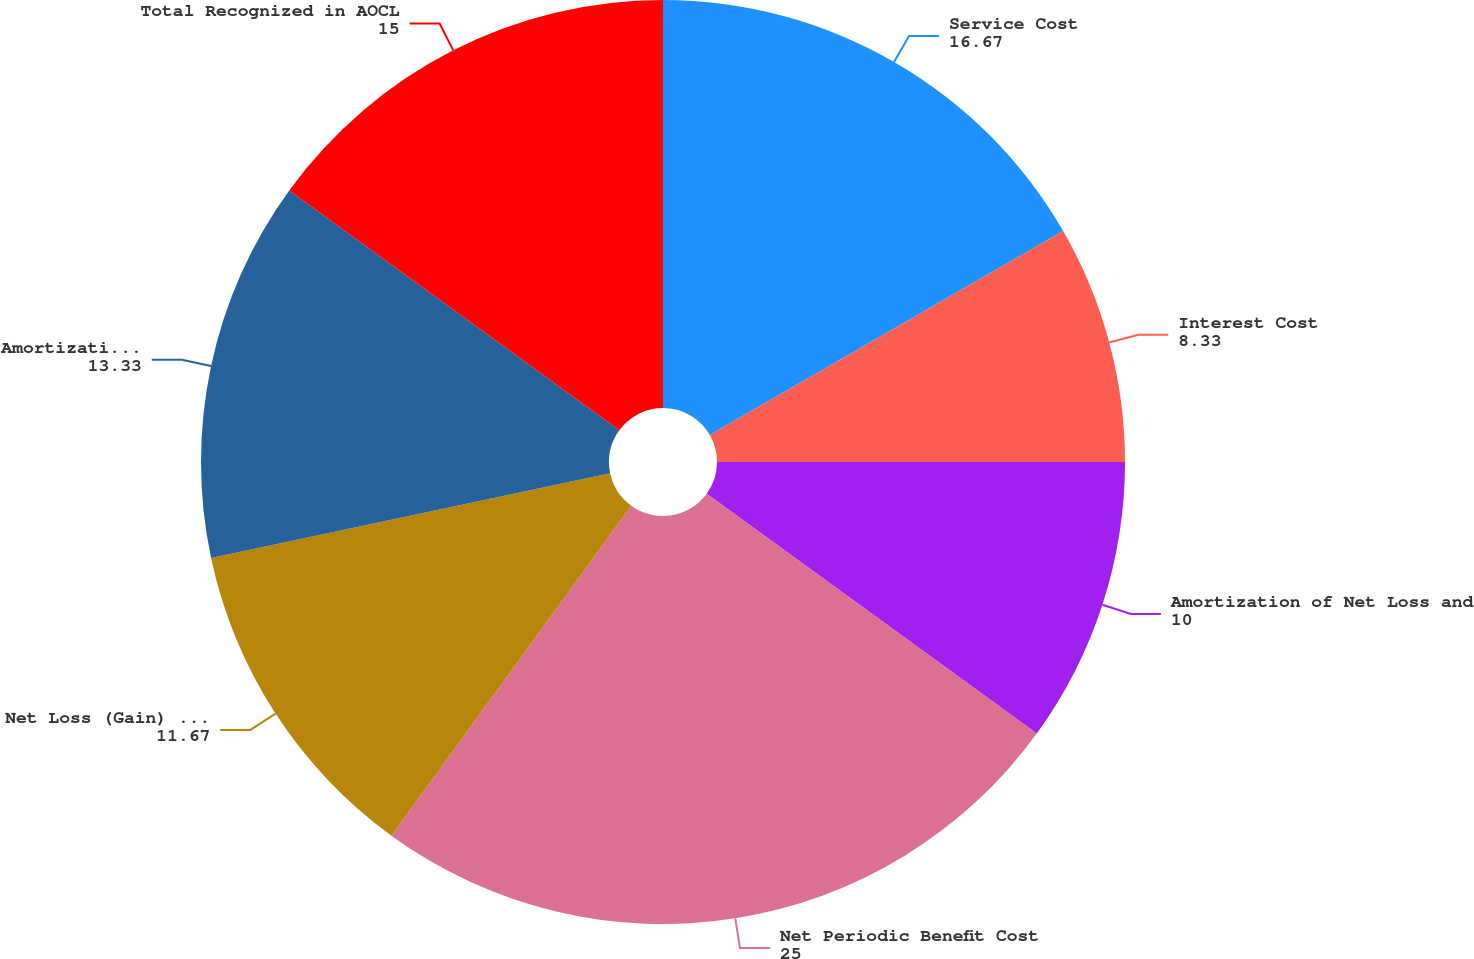<chart> <loc_0><loc_0><loc_500><loc_500><pie_chart><fcel>Service Cost<fcel>Interest Cost<fcel>Amortization of Net Loss and<fcel>Net Periodic Benefit Cost<fcel>Net Loss (Gain) Arising During<fcel>Amortization of Net Loss<fcel>Total Recognized in AOCL<nl><fcel>16.67%<fcel>8.33%<fcel>10.0%<fcel>25.0%<fcel>11.67%<fcel>13.33%<fcel>15.0%<nl></chart> 